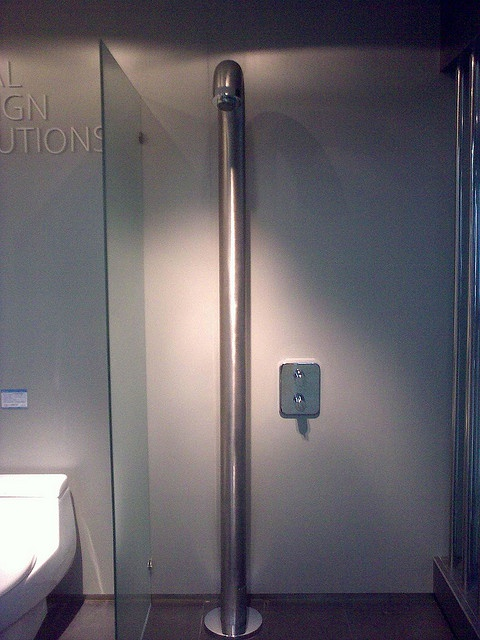Describe the objects in this image and their specific colors. I can see a toilet in black, white, gray, darkgray, and purple tones in this image. 